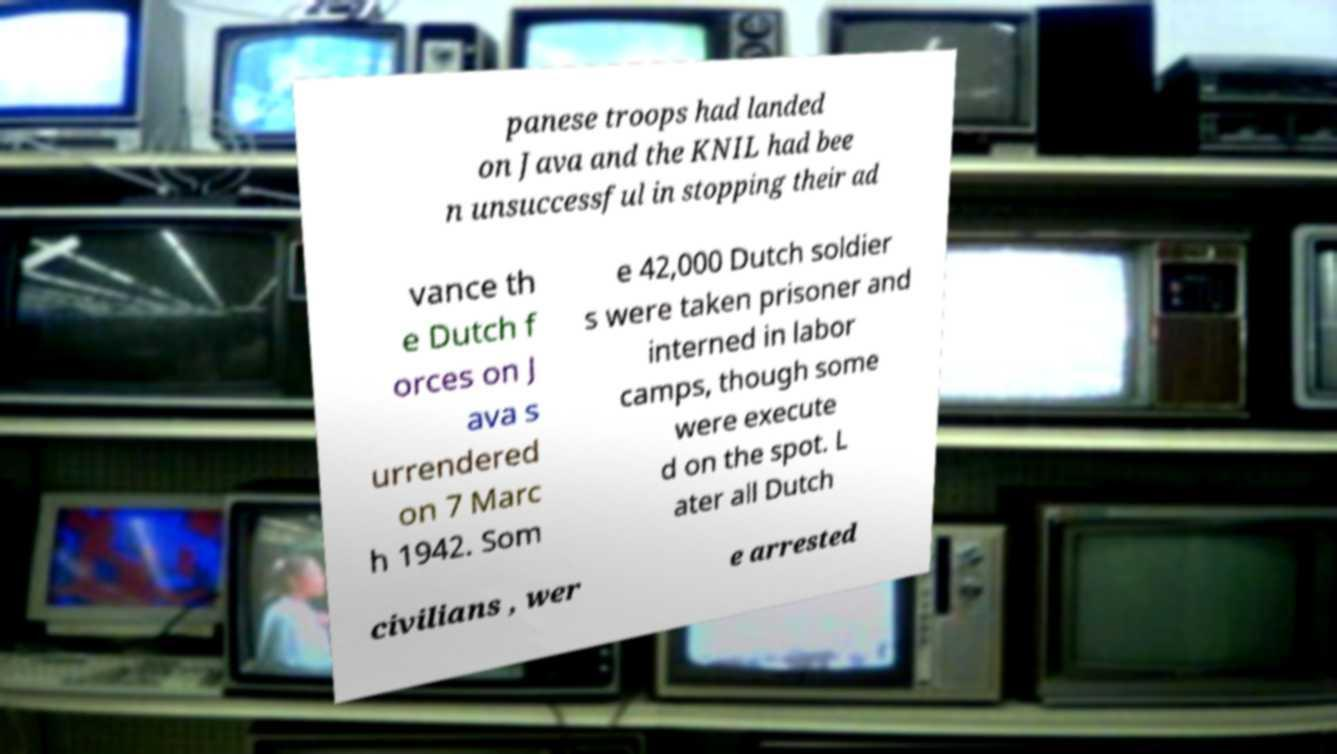Could you assist in decoding the text presented in this image and type it out clearly? panese troops had landed on Java and the KNIL had bee n unsuccessful in stopping their ad vance th e Dutch f orces on J ava s urrendered on 7 Marc h 1942. Som e 42,000 Dutch soldier s were taken prisoner and interned in labor camps, though some were execute d on the spot. L ater all Dutch civilians , wer e arrested 